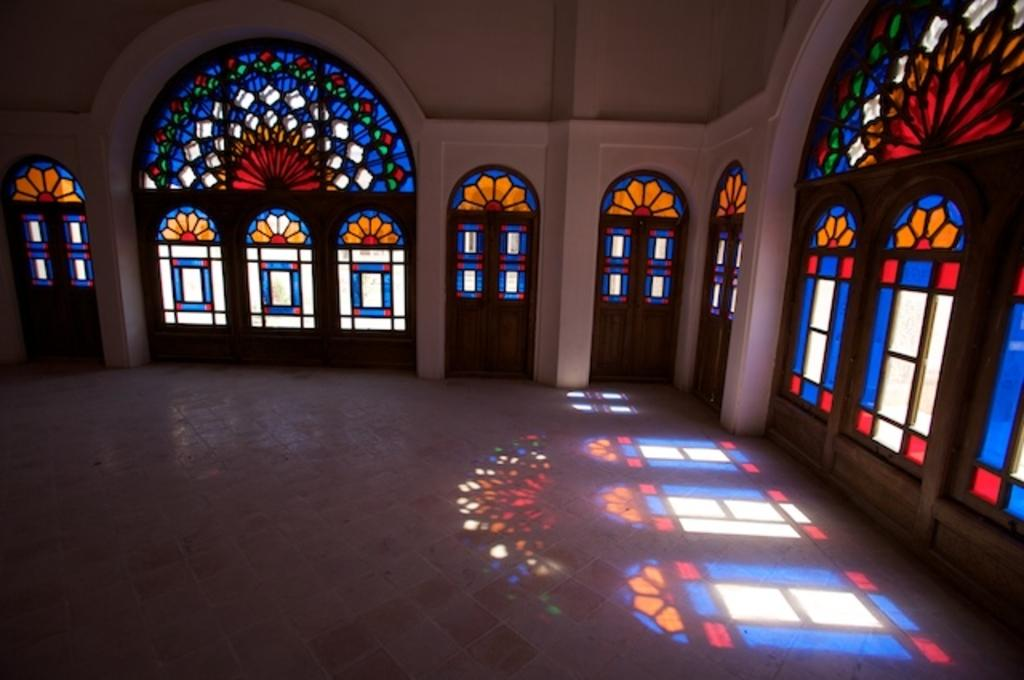What type of space is depicted in the image? The image shows an inside view of a room or hall. What architectural features can be seen in the image? Doors, glass windows, pillars, and arches are visible in the image. What type of bead is hanging from the arches in the image? There are no beads hanging from the arches in the image. How does the quill contribute to the architectural design of the room in the image? There is no quill present in the image, so it does not contribute to the architectural design. 